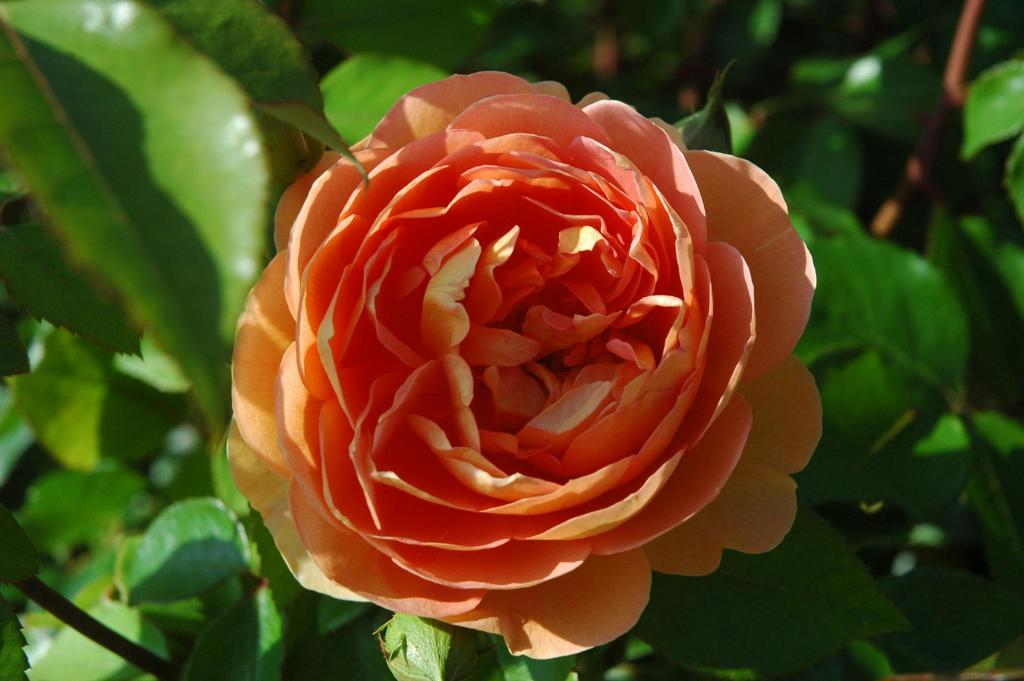What type of flower is in the image? There is a rose flower in the image. What can be seen in the background of the image? There are trees in the background of the image. How many chickens are in the image? There are no chickens present in the image. 